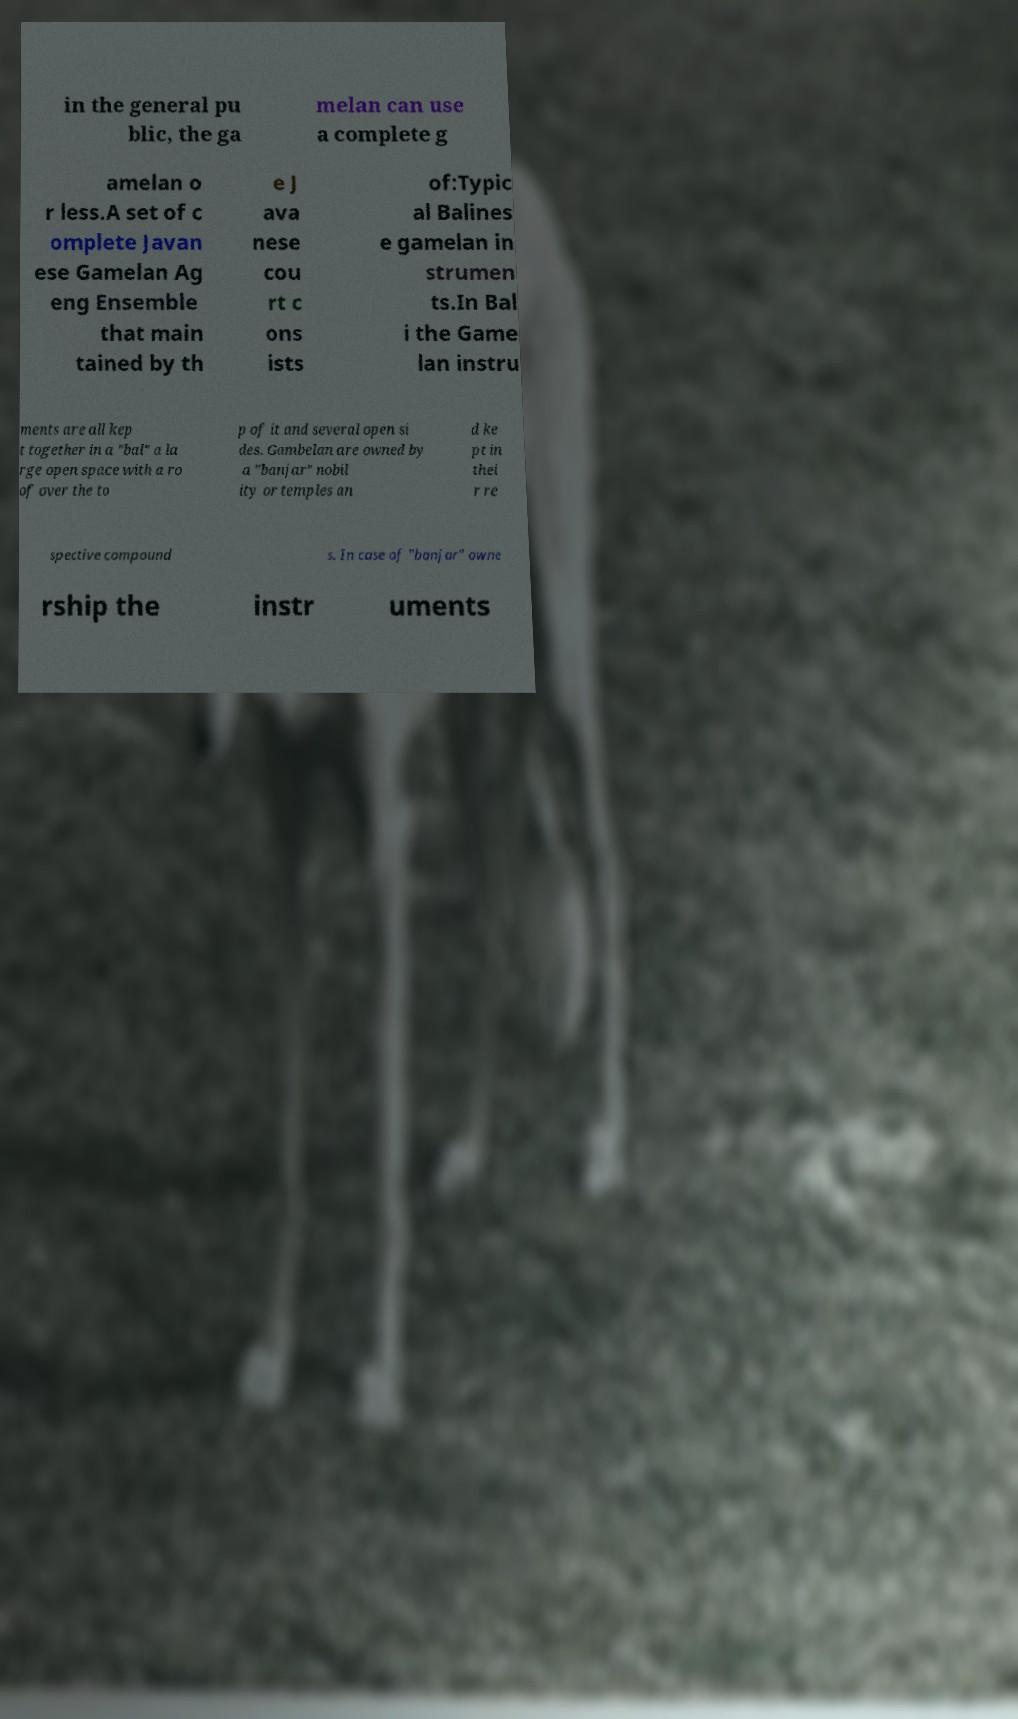Could you extract and type out the text from this image? in the general pu blic, the ga melan can use a complete g amelan o r less.A set of c omplete Javan ese Gamelan Ag eng Ensemble that main tained by th e J ava nese cou rt c ons ists of:Typic al Balines e gamelan in strumen ts.In Bal i the Game lan instru ments are all kep t together in a "bal" a la rge open space with a ro of over the to p of it and several open si des. Gambelan are owned by a "banjar" nobil ity or temples an d ke pt in thei r re spective compound s. In case of "banjar" owne rship the instr uments 